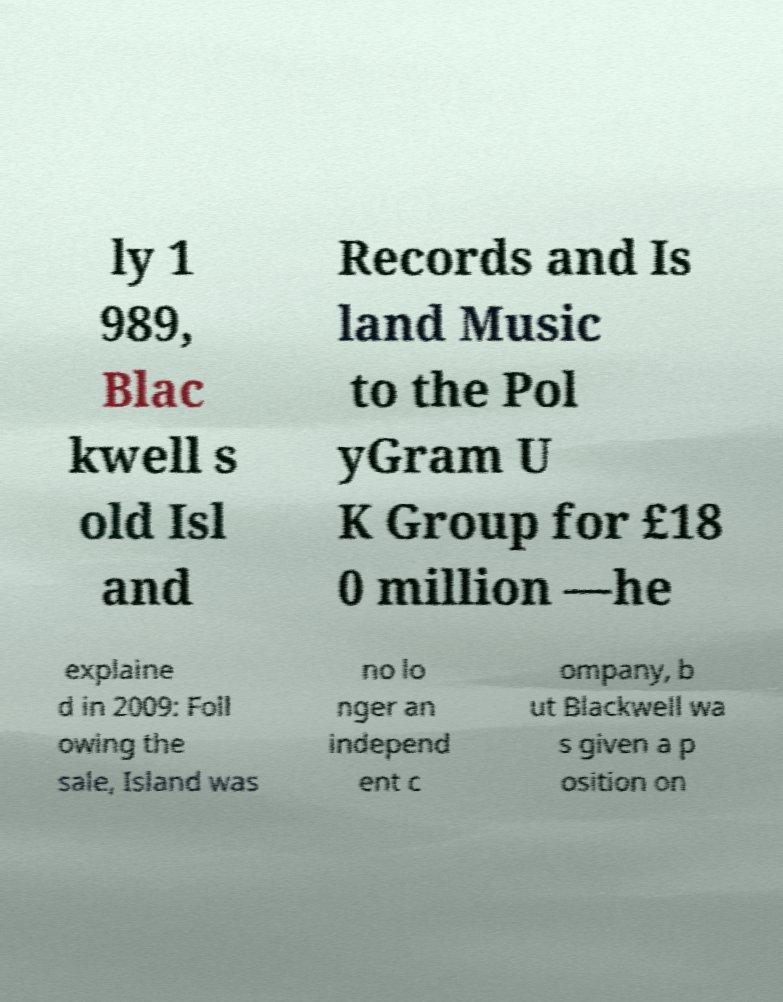Could you assist in decoding the text presented in this image and type it out clearly? ly 1 989, Blac kwell s old Isl and Records and Is land Music to the Pol yGram U K Group for £18 0 million —he explaine d in 2009: Foll owing the sale, Island was no lo nger an independ ent c ompany, b ut Blackwell wa s given a p osition on 